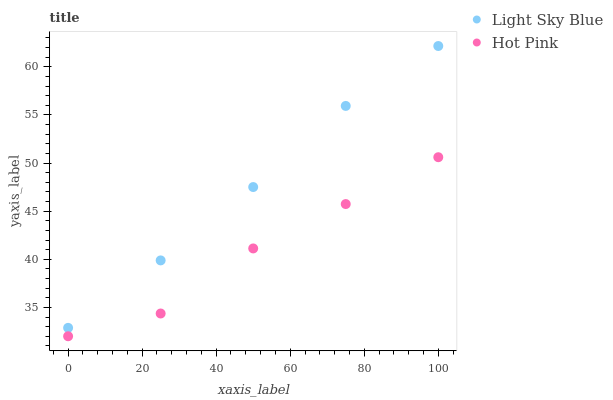Does Hot Pink have the minimum area under the curve?
Answer yes or no. Yes. Does Light Sky Blue have the maximum area under the curve?
Answer yes or no. Yes. Does Hot Pink have the maximum area under the curve?
Answer yes or no. No. Is Light Sky Blue the smoothest?
Answer yes or no. Yes. Is Hot Pink the roughest?
Answer yes or no. Yes. Is Hot Pink the smoothest?
Answer yes or no. No. Does Hot Pink have the lowest value?
Answer yes or no. Yes. Does Light Sky Blue have the highest value?
Answer yes or no. Yes. Does Hot Pink have the highest value?
Answer yes or no. No. Is Hot Pink less than Light Sky Blue?
Answer yes or no. Yes. Is Light Sky Blue greater than Hot Pink?
Answer yes or no. Yes. Does Hot Pink intersect Light Sky Blue?
Answer yes or no. No. 